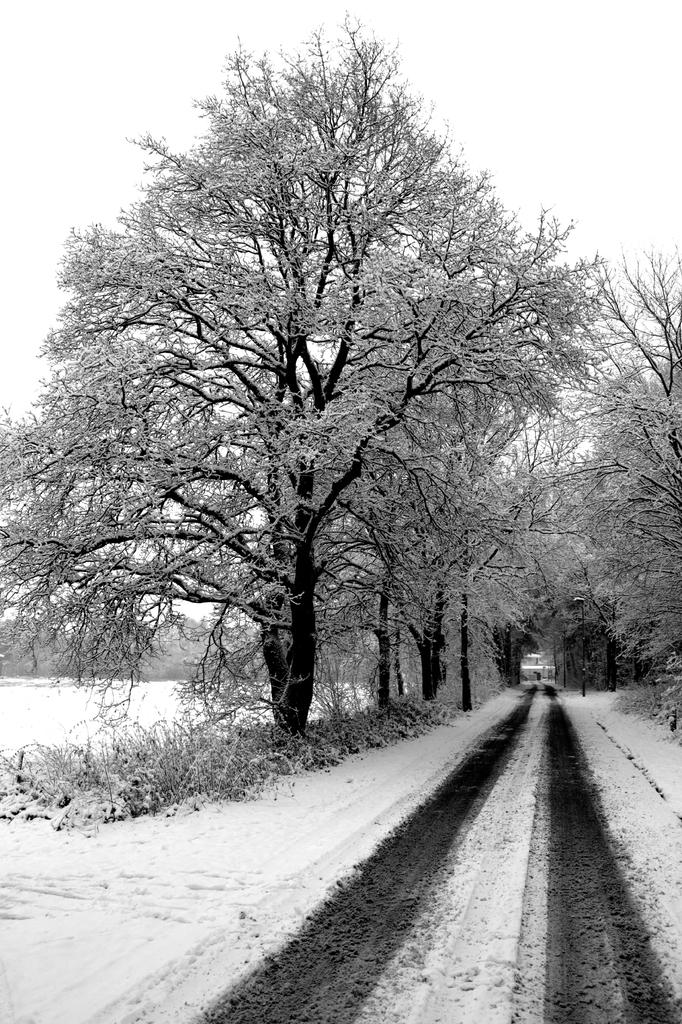What is the main feature of the image? There is a road in the image. What can be seen on the left side of the road? There is a tree on the left side of the road. What type of vegetation is present in the image? There are plants in the image. How is the tree and the plants depicted in the image? The plants and the tree are covered with snow. What type of vessel is being used to transport the cactus in the image? There is no vessel or cactus present in the image. 